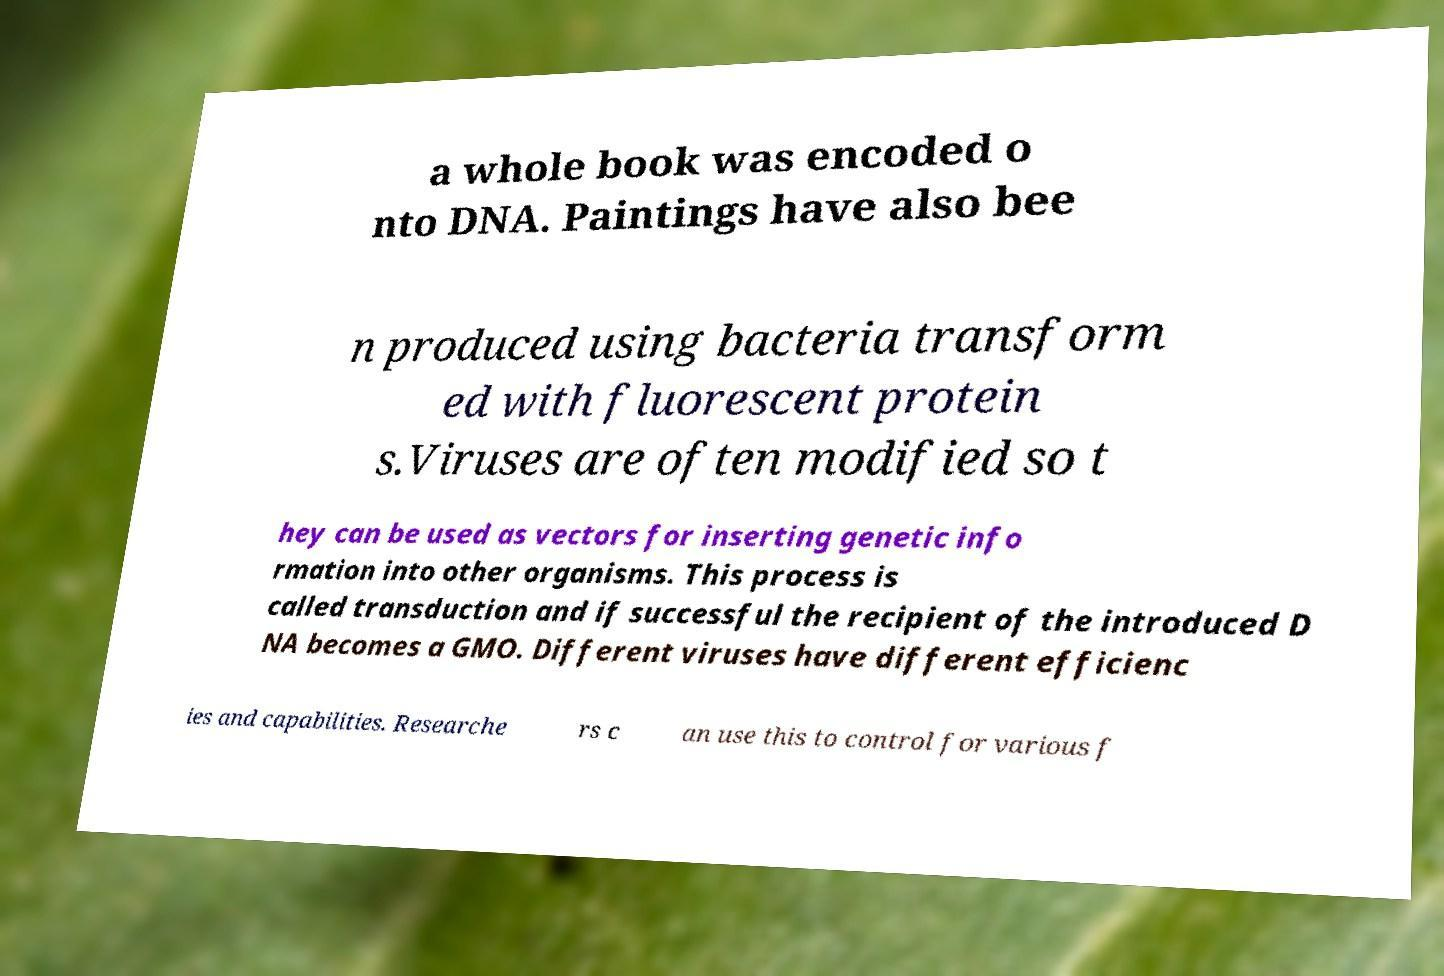I need the written content from this picture converted into text. Can you do that? a whole book was encoded o nto DNA. Paintings have also bee n produced using bacteria transform ed with fluorescent protein s.Viruses are often modified so t hey can be used as vectors for inserting genetic info rmation into other organisms. This process is called transduction and if successful the recipient of the introduced D NA becomes a GMO. Different viruses have different efficienc ies and capabilities. Researche rs c an use this to control for various f 